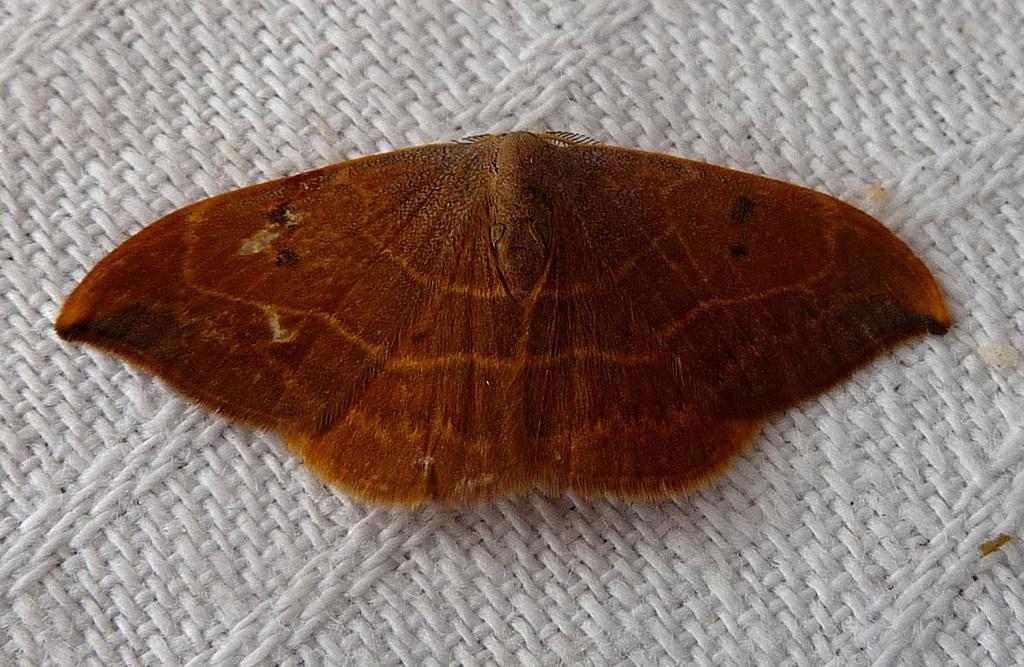In one or two sentences, can you explain what this image depicts? In this picture we can see a butterfly, at the bottom there is a cloth. 